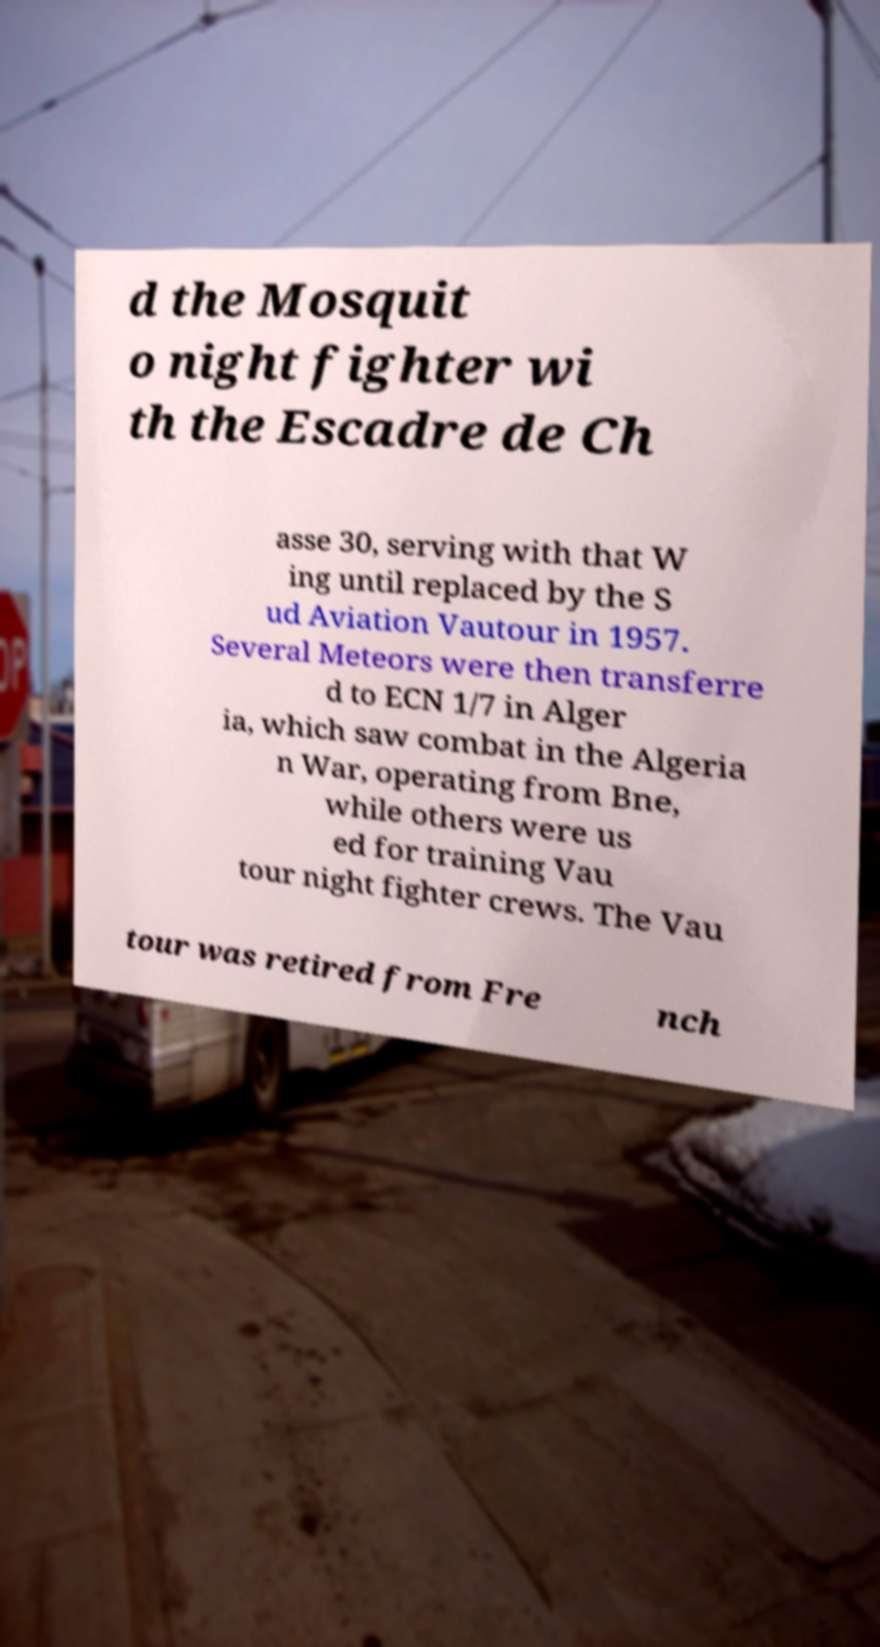For documentation purposes, I need the text within this image transcribed. Could you provide that? d the Mosquit o night fighter wi th the Escadre de Ch asse 30, serving with that W ing until replaced by the S ud Aviation Vautour in 1957. Several Meteors were then transferre d to ECN 1/7 in Alger ia, which saw combat in the Algeria n War, operating from Bne, while others were us ed for training Vau tour night fighter crews. The Vau tour was retired from Fre nch 